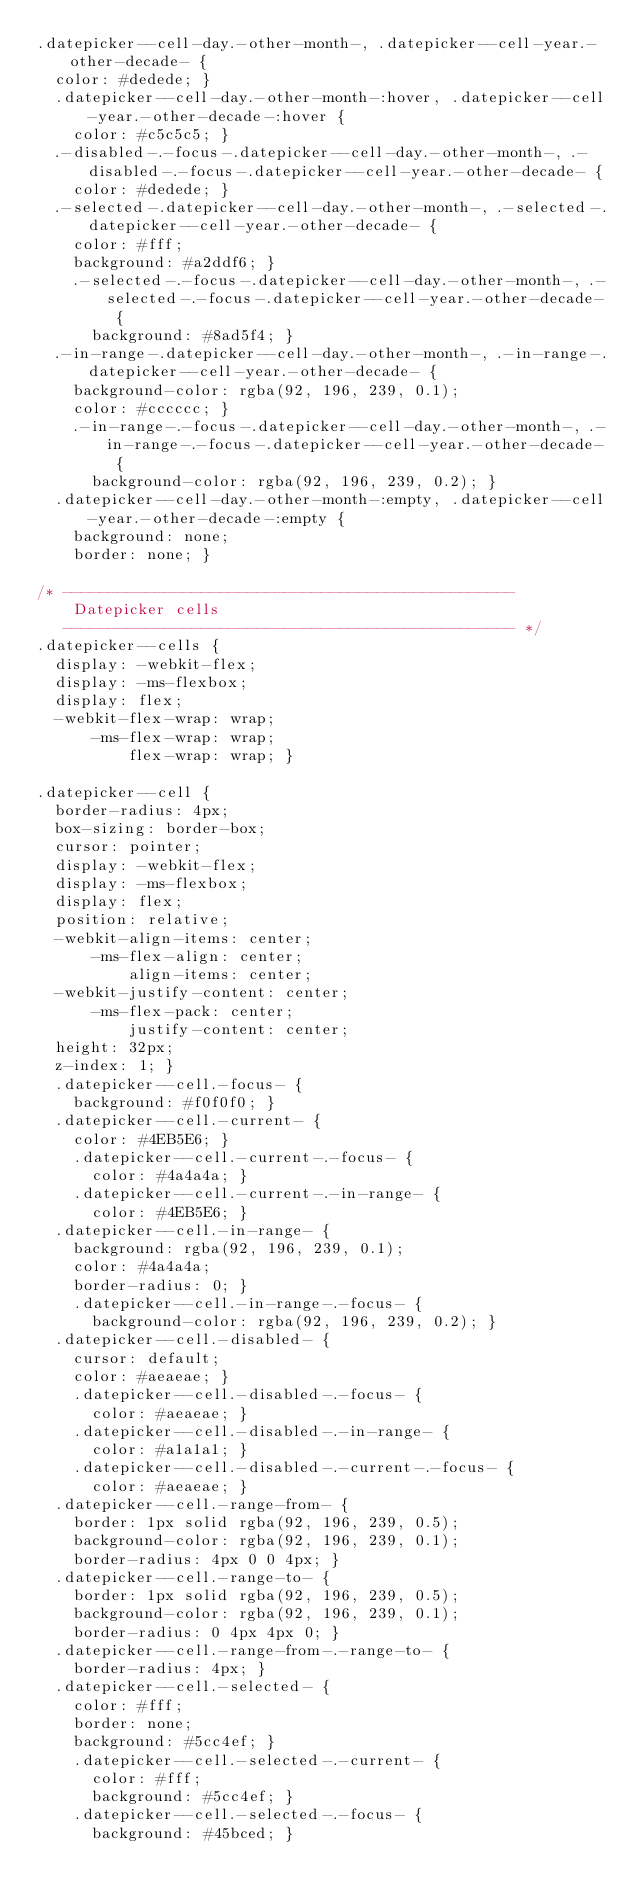<code> <loc_0><loc_0><loc_500><loc_500><_CSS_>.datepicker--cell-day.-other-month-, .datepicker--cell-year.-other-decade- {
  color: #dedede; }
  .datepicker--cell-day.-other-month-:hover, .datepicker--cell-year.-other-decade-:hover {
    color: #c5c5c5; }
  .-disabled-.-focus-.datepicker--cell-day.-other-month-, .-disabled-.-focus-.datepicker--cell-year.-other-decade- {
    color: #dedede; }
  .-selected-.datepicker--cell-day.-other-month-, .-selected-.datepicker--cell-year.-other-decade- {
    color: #fff;
    background: #a2ddf6; }
    .-selected-.-focus-.datepicker--cell-day.-other-month-, .-selected-.-focus-.datepicker--cell-year.-other-decade- {
      background: #8ad5f4; }
  .-in-range-.datepicker--cell-day.-other-month-, .-in-range-.datepicker--cell-year.-other-decade- {
    background-color: rgba(92, 196, 239, 0.1);
    color: #cccccc; }
    .-in-range-.-focus-.datepicker--cell-day.-other-month-, .-in-range-.-focus-.datepicker--cell-year.-other-decade- {
      background-color: rgba(92, 196, 239, 0.2); }
  .datepicker--cell-day.-other-month-:empty, .datepicker--cell-year.-other-decade-:empty {
    background: none;
    border: none; }

/* -------------------------------------------------
    Datepicker cells
   ------------------------------------------------- */
.datepicker--cells {
  display: -webkit-flex;
  display: -ms-flexbox;
  display: flex;
  -webkit-flex-wrap: wrap;
      -ms-flex-wrap: wrap;
          flex-wrap: wrap; }

.datepicker--cell {
  border-radius: 4px;
  box-sizing: border-box;
  cursor: pointer;
  display: -webkit-flex;
  display: -ms-flexbox;
  display: flex;
  position: relative;
  -webkit-align-items: center;
      -ms-flex-align: center;
          align-items: center;
  -webkit-justify-content: center;
      -ms-flex-pack: center;
          justify-content: center;
  height: 32px;
  z-index: 1; }
  .datepicker--cell.-focus- {
    background: #f0f0f0; }
  .datepicker--cell.-current- {
    color: #4EB5E6; }
    .datepicker--cell.-current-.-focus- {
      color: #4a4a4a; }
    .datepicker--cell.-current-.-in-range- {
      color: #4EB5E6; }
  .datepicker--cell.-in-range- {
    background: rgba(92, 196, 239, 0.1);
    color: #4a4a4a;
    border-radius: 0; }
    .datepicker--cell.-in-range-.-focus- {
      background-color: rgba(92, 196, 239, 0.2); }
  .datepicker--cell.-disabled- {
    cursor: default;
    color: #aeaeae; }
    .datepicker--cell.-disabled-.-focus- {
      color: #aeaeae; }
    .datepicker--cell.-disabled-.-in-range- {
      color: #a1a1a1; }
    .datepicker--cell.-disabled-.-current-.-focus- {
      color: #aeaeae; }
  .datepicker--cell.-range-from- {
    border: 1px solid rgba(92, 196, 239, 0.5);
    background-color: rgba(92, 196, 239, 0.1);
    border-radius: 4px 0 0 4px; }
  .datepicker--cell.-range-to- {
    border: 1px solid rgba(92, 196, 239, 0.5);
    background-color: rgba(92, 196, 239, 0.1);
    border-radius: 0 4px 4px 0; }
  .datepicker--cell.-range-from-.-range-to- {
    border-radius: 4px; }
  .datepicker--cell.-selected- {
    color: #fff;
    border: none;
    background: #5cc4ef; }
    .datepicker--cell.-selected-.-current- {
      color: #fff;
      background: #5cc4ef; }
    .datepicker--cell.-selected-.-focus- {
      background: #45bced; }</code> 